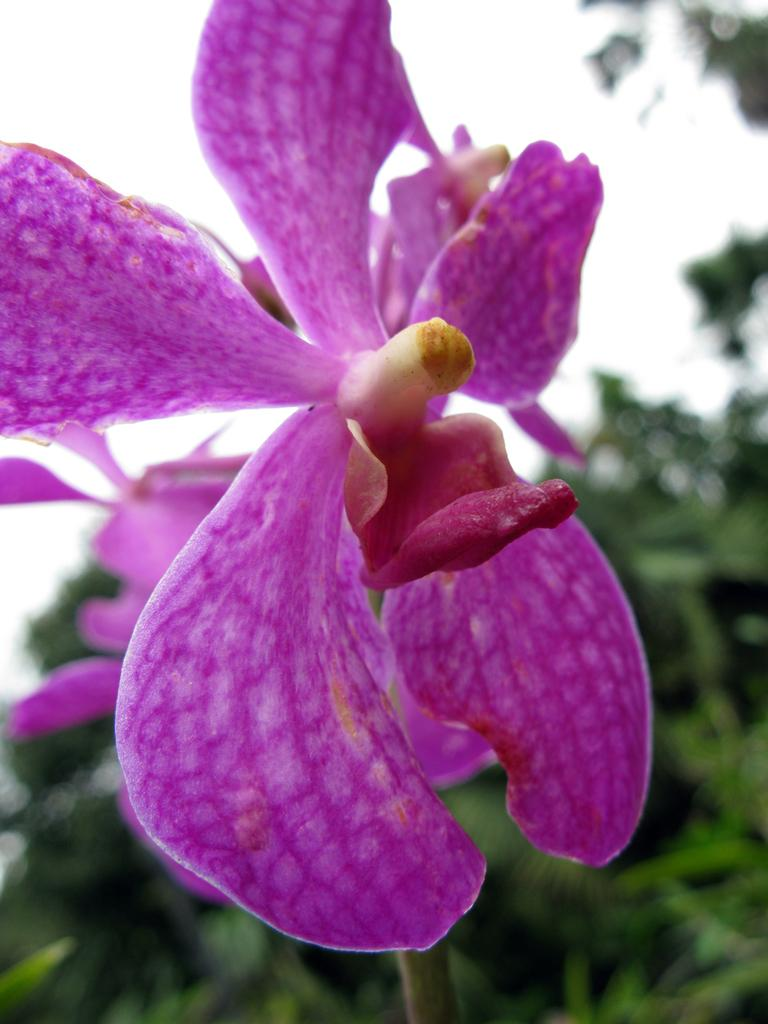What color are the flowers in the image? The flowers in the image are violet. What else can be seen in the background of the image besides the flowers? Many leaves are visible in the background of the image. What is visible at the top of the image? The sky is visible at the top of the image. How much money is being exchanged in the image? There is no money or exchange of money depicted in the image. What time of day is it in the image, considering the night theme? The image does not depict a night theme, and the time of day cannot be determined from the information provided. 